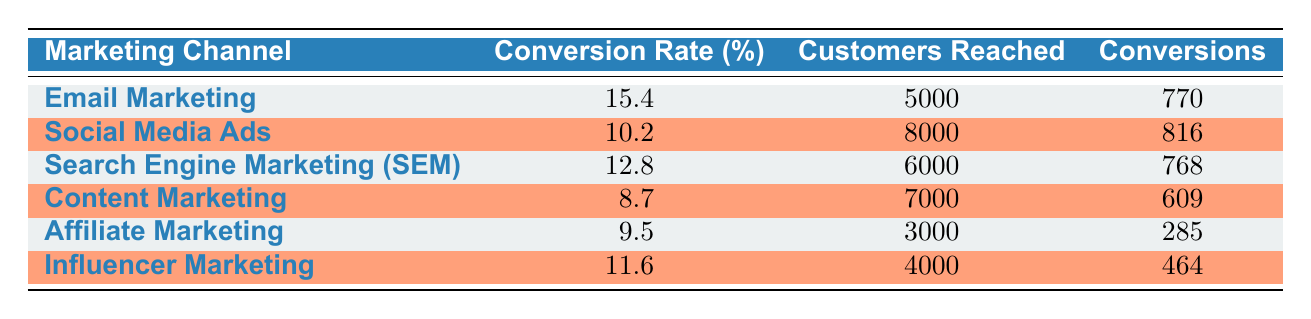What is the conversion rate for Email Marketing? The table lists the conversion rates for various marketing channels. The row for Email Marketing shows a conversion rate of 15.4%.
Answer: 15.4% Which marketing channel reached the most customers? By comparing the values in the "Customers Reached" column, Social Media Ads has the highest number at 8000 customers reached.
Answer: Social Media Ads What is the total number of conversions for all marketing channels combined? To find the total conversions, sum the conversions for each channel: 770 + 816 + 768 + 609 + 285 + 464 = 3912.
Answer: 3912 Is the conversion rate for Influencer Marketing greater than that for Content Marketing? From the table, Influencer Marketing has a conversion rate of 11.6% while Content Marketing has 8.7%. Since 11.6% is greater than 8.7%, the statement is true.
Answer: Yes What is the average conversion rate for all marketing channels? The conversion rates are 15.4, 10.2, 12.8, 8.7, 9.5, and 11.6. Sum these values: 15.4 + 10.2 + 12.8 + 8.7 + 9.5 + 11.6 = 68.2. There are 6 channels, so the average is 68.2 / 6 = 11.37.
Answer: 11.37 How many customers were reached by Affiliate Marketing? The table specifies that Affiliate Marketing reached 3000 customers.
Answer: 3000 Which marketing channel had the highest conversion rate? By comparing the conversion rates in the table, Email Marketing has the highest rate at 15.4%.
Answer: Email Marketing Are the total customers reached by Search Engine Marketing (SEM) and Content Marketing greater than those reached by Email Marketing? Search Engine Marketing reached 6000 customers, and Content Marketing reached 7000 customers. Combined, they reached 6000 + 7000 = 13000. Email Marketing reached 5000 customers, so 13000 > 5000.
Answer: Yes 